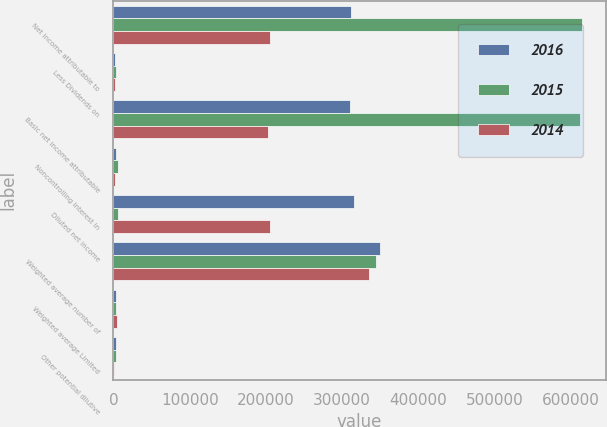<chart> <loc_0><loc_0><loc_500><loc_500><stacked_bar_chart><ecel><fcel>Net income attributable to<fcel>Less Dividends on<fcel>Basic net income attributable<fcel>Noncontrolling interest in<fcel>Diluted net income<fcel>Weighted average number of<fcel>Weighted average Limited<fcel>Other potential dilutive<nl><fcel>2016<fcel>312143<fcel>2356<fcel>309787<fcel>3089<fcel>315232<fcel>349942<fcel>3481<fcel>3653<nl><fcel>2015<fcel>615310<fcel>3081<fcel>612229<fcel>6404<fcel>6404<fcel>345057<fcel>3582<fcel>3558<nl><fcel>2014<fcel>204893<fcel>2588<fcel>202305<fcel>2627<fcel>204932<fcel>335777<fcel>4308<fcel>361<nl></chart> 